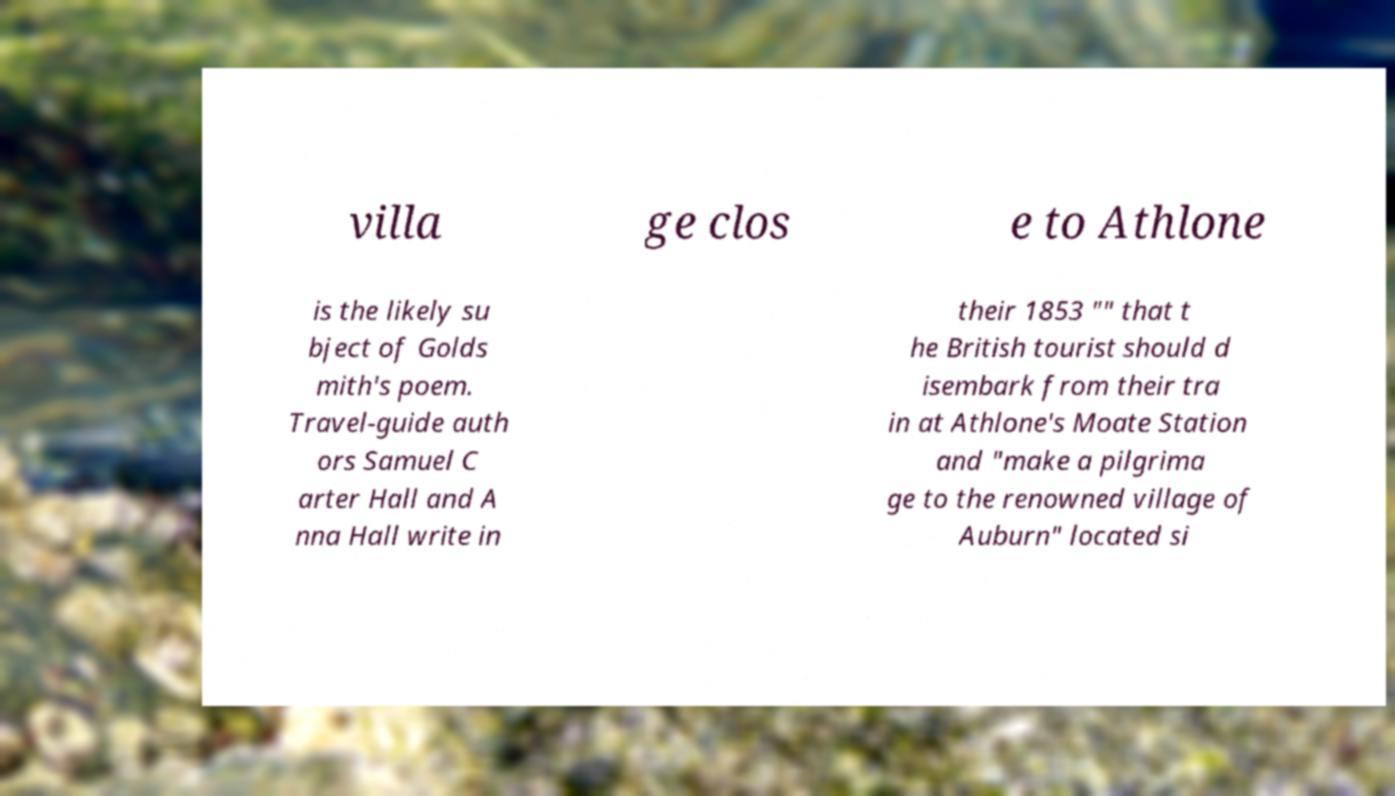Please identify and transcribe the text found in this image. villa ge clos e to Athlone is the likely su bject of Golds mith's poem. Travel-guide auth ors Samuel C arter Hall and A nna Hall write in their 1853 "" that t he British tourist should d isembark from their tra in at Athlone's Moate Station and "make a pilgrima ge to the renowned village of Auburn" located si 